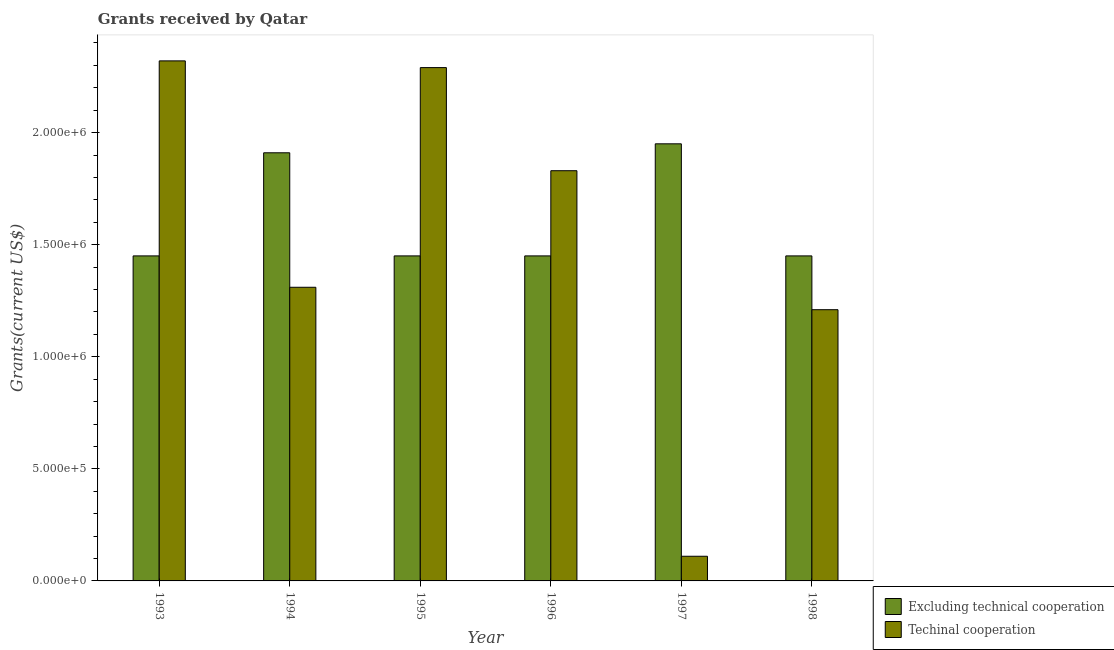How many groups of bars are there?
Your answer should be compact. 6. How many bars are there on the 4th tick from the right?
Offer a very short reply. 2. What is the label of the 5th group of bars from the left?
Your answer should be compact. 1997. In how many cases, is the number of bars for a given year not equal to the number of legend labels?
Your answer should be compact. 0. What is the amount of grants received(including technical cooperation) in 1995?
Ensure brevity in your answer.  2.29e+06. Across all years, what is the maximum amount of grants received(excluding technical cooperation)?
Your answer should be very brief. 1.95e+06. Across all years, what is the minimum amount of grants received(excluding technical cooperation)?
Give a very brief answer. 1.45e+06. In which year was the amount of grants received(including technical cooperation) maximum?
Your response must be concise. 1993. What is the total amount of grants received(excluding technical cooperation) in the graph?
Offer a terse response. 9.66e+06. What is the difference between the amount of grants received(excluding technical cooperation) in 1994 and that in 1997?
Provide a succinct answer. -4.00e+04. What is the difference between the amount of grants received(including technical cooperation) in 1997 and the amount of grants received(excluding technical cooperation) in 1995?
Offer a very short reply. -2.18e+06. What is the average amount of grants received(including technical cooperation) per year?
Offer a terse response. 1.51e+06. In the year 1993, what is the difference between the amount of grants received(including technical cooperation) and amount of grants received(excluding technical cooperation)?
Your answer should be compact. 0. What is the ratio of the amount of grants received(excluding technical cooperation) in 1994 to that in 1996?
Provide a short and direct response. 1.32. What is the difference between the highest and the lowest amount of grants received(excluding technical cooperation)?
Your response must be concise. 5.00e+05. In how many years, is the amount of grants received(including technical cooperation) greater than the average amount of grants received(including technical cooperation) taken over all years?
Your answer should be compact. 3. Is the sum of the amount of grants received(including technical cooperation) in 1997 and 1998 greater than the maximum amount of grants received(excluding technical cooperation) across all years?
Provide a succinct answer. No. What does the 2nd bar from the left in 1997 represents?
Your answer should be very brief. Techinal cooperation. What does the 1st bar from the right in 1998 represents?
Offer a very short reply. Techinal cooperation. How many bars are there?
Your response must be concise. 12. Are the values on the major ticks of Y-axis written in scientific E-notation?
Your response must be concise. Yes. Does the graph contain any zero values?
Offer a terse response. No. How are the legend labels stacked?
Give a very brief answer. Vertical. What is the title of the graph?
Provide a succinct answer. Grants received by Qatar. What is the label or title of the Y-axis?
Your response must be concise. Grants(current US$). What is the Grants(current US$) in Excluding technical cooperation in 1993?
Your answer should be very brief. 1.45e+06. What is the Grants(current US$) in Techinal cooperation in 1993?
Your response must be concise. 2.32e+06. What is the Grants(current US$) in Excluding technical cooperation in 1994?
Offer a terse response. 1.91e+06. What is the Grants(current US$) of Techinal cooperation in 1994?
Make the answer very short. 1.31e+06. What is the Grants(current US$) in Excluding technical cooperation in 1995?
Provide a short and direct response. 1.45e+06. What is the Grants(current US$) in Techinal cooperation in 1995?
Make the answer very short. 2.29e+06. What is the Grants(current US$) of Excluding technical cooperation in 1996?
Your answer should be compact. 1.45e+06. What is the Grants(current US$) in Techinal cooperation in 1996?
Provide a succinct answer. 1.83e+06. What is the Grants(current US$) in Excluding technical cooperation in 1997?
Make the answer very short. 1.95e+06. What is the Grants(current US$) of Excluding technical cooperation in 1998?
Your answer should be very brief. 1.45e+06. What is the Grants(current US$) of Techinal cooperation in 1998?
Give a very brief answer. 1.21e+06. Across all years, what is the maximum Grants(current US$) in Excluding technical cooperation?
Provide a short and direct response. 1.95e+06. Across all years, what is the maximum Grants(current US$) in Techinal cooperation?
Your answer should be very brief. 2.32e+06. Across all years, what is the minimum Grants(current US$) in Excluding technical cooperation?
Provide a short and direct response. 1.45e+06. What is the total Grants(current US$) of Excluding technical cooperation in the graph?
Provide a succinct answer. 9.66e+06. What is the total Grants(current US$) in Techinal cooperation in the graph?
Your answer should be compact. 9.07e+06. What is the difference between the Grants(current US$) in Excluding technical cooperation in 1993 and that in 1994?
Your response must be concise. -4.60e+05. What is the difference between the Grants(current US$) in Techinal cooperation in 1993 and that in 1994?
Offer a terse response. 1.01e+06. What is the difference between the Grants(current US$) of Excluding technical cooperation in 1993 and that in 1995?
Offer a terse response. 0. What is the difference between the Grants(current US$) of Techinal cooperation in 1993 and that in 1996?
Your response must be concise. 4.90e+05. What is the difference between the Grants(current US$) of Excluding technical cooperation in 1993 and that in 1997?
Your answer should be very brief. -5.00e+05. What is the difference between the Grants(current US$) in Techinal cooperation in 1993 and that in 1997?
Provide a short and direct response. 2.21e+06. What is the difference between the Grants(current US$) of Techinal cooperation in 1993 and that in 1998?
Your response must be concise. 1.11e+06. What is the difference between the Grants(current US$) of Techinal cooperation in 1994 and that in 1995?
Make the answer very short. -9.80e+05. What is the difference between the Grants(current US$) in Excluding technical cooperation in 1994 and that in 1996?
Offer a terse response. 4.60e+05. What is the difference between the Grants(current US$) of Techinal cooperation in 1994 and that in 1996?
Ensure brevity in your answer.  -5.20e+05. What is the difference between the Grants(current US$) of Techinal cooperation in 1994 and that in 1997?
Your answer should be very brief. 1.20e+06. What is the difference between the Grants(current US$) in Excluding technical cooperation in 1995 and that in 1996?
Provide a succinct answer. 0. What is the difference between the Grants(current US$) of Excluding technical cooperation in 1995 and that in 1997?
Provide a succinct answer. -5.00e+05. What is the difference between the Grants(current US$) in Techinal cooperation in 1995 and that in 1997?
Make the answer very short. 2.18e+06. What is the difference between the Grants(current US$) of Excluding technical cooperation in 1995 and that in 1998?
Provide a short and direct response. 0. What is the difference between the Grants(current US$) in Techinal cooperation in 1995 and that in 1998?
Keep it short and to the point. 1.08e+06. What is the difference between the Grants(current US$) in Excluding technical cooperation in 1996 and that in 1997?
Make the answer very short. -5.00e+05. What is the difference between the Grants(current US$) in Techinal cooperation in 1996 and that in 1997?
Offer a terse response. 1.72e+06. What is the difference between the Grants(current US$) of Excluding technical cooperation in 1996 and that in 1998?
Provide a short and direct response. 0. What is the difference between the Grants(current US$) in Techinal cooperation in 1996 and that in 1998?
Offer a terse response. 6.20e+05. What is the difference between the Grants(current US$) of Techinal cooperation in 1997 and that in 1998?
Your answer should be compact. -1.10e+06. What is the difference between the Grants(current US$) of Excluding technical cooperation in 1993 and the Grants(current US$) of Techinal cooperation in 1994?
Offer a terse response. 1.40e+05. What is the difference between the Grants(current US$) in Excluding technical cooperation in 1993 and the Grants(current US$) in Techinal cooperation in 1995?
Your answer should be compact. -8.40e+05. What is the difference between the Grants(current US$) of Excluding technical cooperation in 1993 and the Grants(current US$) of Techinal cooperation in 1996?
Give a very brief answer. -3.80e+05. What is the difference between the Grants(current US$) in Excluding technical cooperation in 1993 and the Grants(current US$) in Techinal cooperation in 1997?
Provide a succinct answer. 1.34e+06. What is the difference between the Grants(current US$) of Excluding technical cooperation in 1993 and the Grants(current US$) of Techinal cooperation in 1998?
Provide a short and direct response. 2.40e+05. What is the difference between the Grants(current US$) of Excluding technical cooperation in 1994 and the Grants(current US$) of Techinal cooperation in 1995?
Offer a very short reply. -3.80e+05. What is the difference between the Grants(current US$) in Excluding technical cooperation in 1994 and the Grants(current US$) in Techinal cooperation in 1996?
Your answer should be compact. 8.00e+04. What is the difference between the Grants(current US$) of Excluding technical cooperation in 1994 and the Grants(current US$) of Techinal cooperation in 1997?
Offer a terse response. 1.80e+06. What is the difference between the Grants(current US$) in Excluding technical cooperation in 1994 and the Grants(current US$) in Techinal cooperation in 1998?
Your answer should be very brief. 7.00e+05. What is the difference between the Grants(current US$) of Excluding technical cooperation in 1995 and the Grants(current US$) of Techinal cooperation in 1996?
Ensure brevity in your answer.  -3.80e+05. What is the difference between the Grants(current US$) in Excluding technical cooperation in 1995 and the Grants(current US$) in Techinal cooperation in 1997?
Your response must be concise. 1.34e+06. What is the difference between the Grants(current US$) of Excluding technical cooperation in 1996 and the Grants(current US$) of Techinal cooperation in 1997?
Provide a succinct answer. 1.34e+06. What is the difference between the Grants(current US$) of Excluding technical cooperation in 1997 and the Grants(current US$) of Techinal cooperation in 1998?
Your answer should be compact. 7.40e+05. What is the average Grants(current US$) of Excluding technical cooperation per year?
Your response must be concise. 1.61e+06. What is the average Grants(current US$) in Techinal cooperation per year?
Your answer should be very brief. 1.51e+06. In the year 1993, what is the difference between the Grants(current US$) in Excluding technical cooperation and Grants(current US$) in Techinal cooperation?
Make the answer very short. -8.70e+05. In the year 1994, what is the difference between the Grants(current US$) of Excluding technical cooperation and Grants(current US$) of Techinal cooperation?
Offer a very short reply. 6.00e+05. In the year 1995, what is the difference between the Grants(current US$) in Excluding technical cooperation and Grants(current US$) in Techinal cooperation?
Make the answer very short. -8.40e+05. In the year 1996, what is the difference between the Grants(current US$) in Excluding technical cooperation and Grants(current US$) in Techinal cooperation?
Offer a very short reply. -3.80e+05. In the year 1997, what is the difference between the Grants(current US$) of Excluding technical cooperation and Grants(current US$) of Techinal cooperation?
Your answer should be very brief. 1.84e+06. In the year 1998, what is the difference between the Grants(current US$) in Excluding technical cooperation and Grants(current US$) in Techinal cooperation?
Offer a terse response. 2.40e+05. What is the ratio of the Grants(current US$) of Excluding technical cooperation in 1993 to that in 1994?
Your answer should be compact. 0.76. What is the ratio of the Grants(current US$) in Techinal cooperation in 1993 to that in 1994?
Provide a succinct answer. 1.77. What is the ratio of the Grants(current US$) of Excluding technical cooperation in 1993 to that in 1995?
Provide a succinct answer. 1. What is the ratio of the Grants(current US$) of Techinal cooperation in 1993 to that in 1995?
Your response must be concise. 1.01. What is the ratio of the Grants(current US$) of Excluding technical cooperation in 1993 to that in 1996?
Your answer should be very brief. 1. What is the ratio of the Grants(current US$) in Techinal cooperation in 1993 to that in 1996?
Keep it short and to the point. 1.27. What is the ratio of the Grants(current US$) of Excluding technical cooperation in 1993 to that in 1997?
Keep it short and to the point. 0.74. What is the ratio of the Grants(current US$) in Techinal cooperation in 1993 to that in 1997?
Make the answer very short. 21.09. What is the ratio of the Grants(current US$) in Excluding technical cooperation in 1993 to that in 1998?
Give a very brief answer. 1. What is the ratio of the Grants(current US$) in Techinal cooperation in 1993 to that in 1998?
Keep it short and to the point. 1.92. What is the ratio of the Grants(current US$) in Excluding technical cooperation in 1994 to that in 1995?
Offer a very short reply. 1.32. What is the ratio of the Grants(current US$) in Techinal cooperation in 1994 to that in 1995?
Make the answer very short. 0.57. What is the ratio of the Grants(current US$) in Excluding technical cooperation in 1994 to that in 1996?
Give a very brief answer. 1.32. What is the ratio of the Grants(current US$) of Techinal cooperation in 1994 to that in 1996?
Give a very brief answer. 0.72. What is the ratio of the Grants(current US$) in Excluding technical cooperation in 1994 to that in 1997?
Keep it short and to the point. 0.98. What is the ratio of the Grants(current US$) in Techinal cooperation in 1994 to that in 1997?
Your answer should be very brief. 11.91. What is the ratio of the Grants(current US$) in Excluding technical cooperation in 1994 to that in 1998?
Ensure brevity in your answer.  1.32. What is the ratio of the Grants(current US$) in Techinal cooperation in 1994 to that in 1998?
Your answer should be compact. 1.08. What is the ratio of the Grants(current US$) of Excluding technical cooperation in 1995 to that in 1996?
Offer a very short reply. 1. What is the ratio of the Grants(current US$) in Techinal cooperation in 1995 to that in 1996?
Your response must be concise. 1.25. What is the ratio of the Grants(current US$) in Excluding technical cooperation in 1995 to that in 1997?
Ensure brevity in your answer.  0.74. What is the ratio of the Grants(current US$) in Techinal cooperation in 1995 to that in 1997?
Provide a succinct answer. 20.82. What is the ratio of the Grants(current US$) in Excluding technical cooperation in 1995 to that in 1998?
Offer a terse response. 1. What is the ratio of the Grants(current US$) in Techinal cooperation in 1995 to that in 1998?
Your answer should be very brief. 1.89. What is the ratio of the Grants(current US$) in Excluding technical cooperation in 1996 to that in 1997?
Make the answer very short. 0.74. What is the ratio of the Grants(current US$) in Techinal cooperation in 1996 to that in 1997?
Your response must be concise. 16.64. What is the ratio of the Grants(current US$) in Techinal cooperation in 1996 to that in 1998?
Offer a very short reply. 1.51. What is the ratio of the Grants(current US$) of Excluding technical cooperation in 1997 to that in 1998?
Your response must be concise. 1.34. What is the ratio of the Grants(current US$) of Techinal cooperation in 1997 to that in 1998?
Offer a very short reply. 0.09. What is the difference between the highest and the second highest Grants(current US$) in Excluding technical cooperation?
Keep it short and to the point. 4.00e+04. What is the difference between the highest and the lowest Grants(current US$) of Techinal cooperation?
Keep it short and to the point. 2.21e+06. 